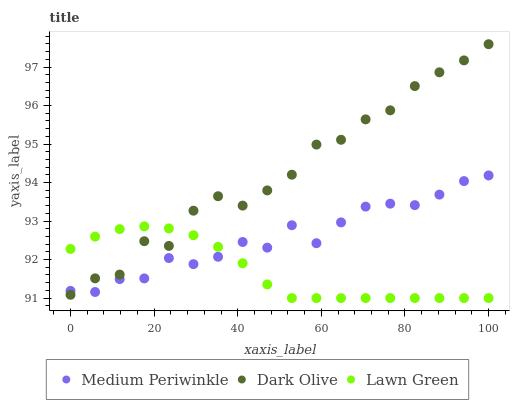Does Lawn Green have the minimum area under the curve?
Answer yes or no. Yes. Does Dark Olive have the maximum area under the curve?
Answer yes or no. Yes. Does Medium Periwinkle have the minimum area under the curve?
Answer yes or no. No. Does Medium Periwinkle have the maximum area under the curve?
Answer yes or no. No. Is Lawn Green the smoothest?
Answer yes or no. Yes. Is Dark Olive the roughest?
Answer yes or no. Yes. Is Medium Periwinkle the smoothest?
Answer yes or no. No. Is Medium Periwinkle the roughest?
Answer yes or no. No. Does Lawn Green have the lowest value?
Answer yes or no. Yes. Does Dark Olive have the lowest value?
Answer yes or no. No. Does Dark Olive have the highest value?
Answer yes or no. Yes. Does Medium Periwinkle have the highest value?
Answer yes or no. No. Does Lawn Green intersect Dark Olive?
Answer yes or no. Yes. Is Lawn Green less than Dark Olive?
Answer yes or no. No. Is Lawn Green greater than Dark Olive?
Answer yes or no. No. 